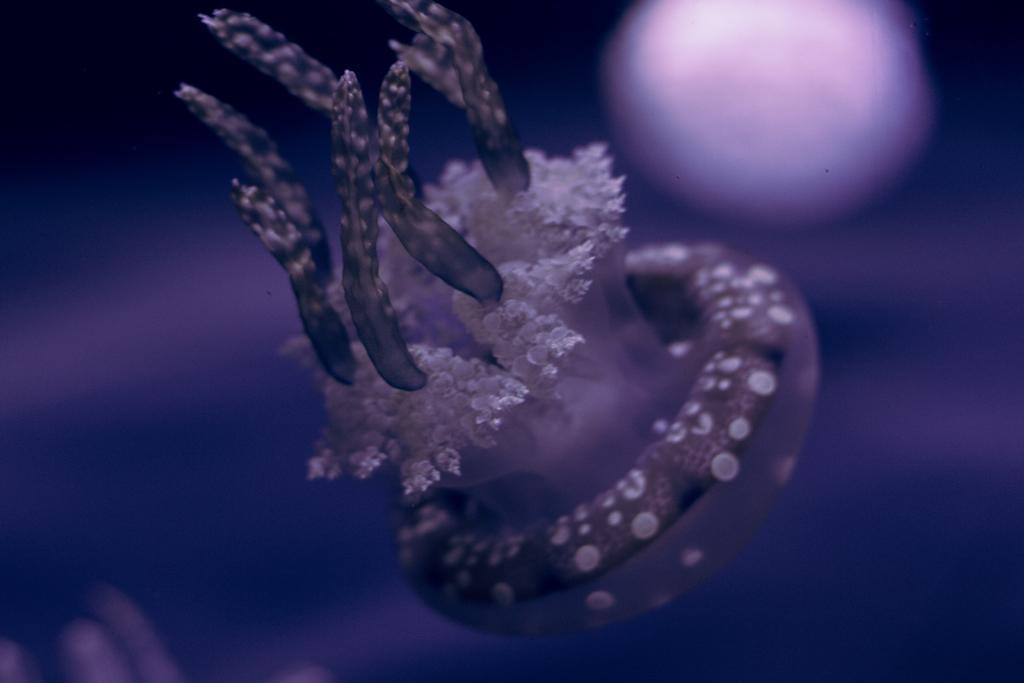Can you describe this image briefly? In the picture I can see an object and the background is in violet color. 